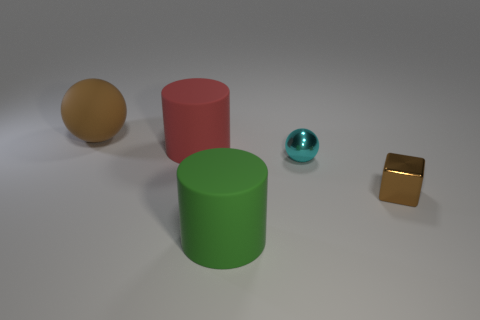How many small cyan metal objects are there?
Your answer should be compact. 1. Is the material of the brown object that is right of the green rubber object the same as the cylinder in front of the small cyan shiny object?
Provide a short and direct response. No. What is the size of the brown object that is the same material as the large green cylinder?
Offer a terse response. Large. The brown thing in front of the brown sphere has what shape?
Ensure brevity in your answer.  Cube. There is a rubber object on the left side of the big red object; does it have the same color as the small object that is on the left side of the tiny brown metal block?
Keep it short and to the point. No. What size is the cube that is the same color as the matte sphere?
Make the answer very short. Small. Are there any big yellow things?
Your response must be concise. No. There is a big object in front of the object that is on the right side of the sphere in front of the brown matte object; what shape is it?
Make the answer very short. Cylinder. There is a brown matte sphere; what number of big green matte objects are on the left side of it?
Offer a terse response. 0. Are the sphere on the left side of the small metal ball and the brown block made of the same material?
Your answer should be very brief. No. 